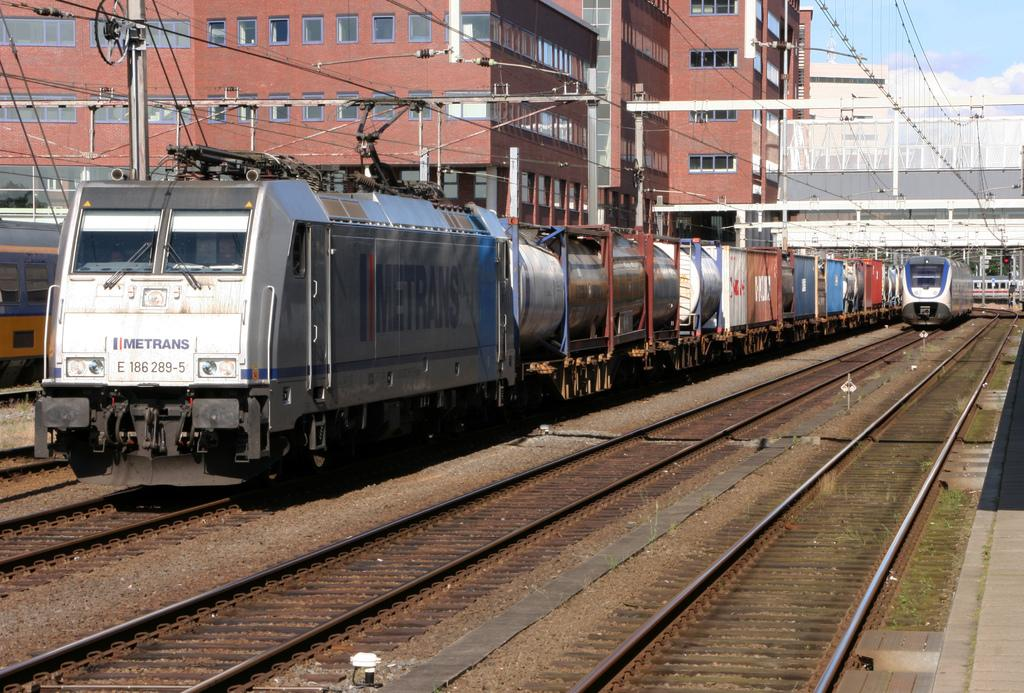<image>
Describe the image concisely. A Metrans train traces along a set of tracks in the city. 